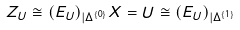<formula> <loc_0><loc_0><loc_500><loc_500>Z _ { U } \cong ( E _ { U } ) _ { | \Delta ^ { \{ 0 \} } } X = U \cong ( E _ { U } ) _ { | \Delta ^ { \{ 1 \} } }</formula> 